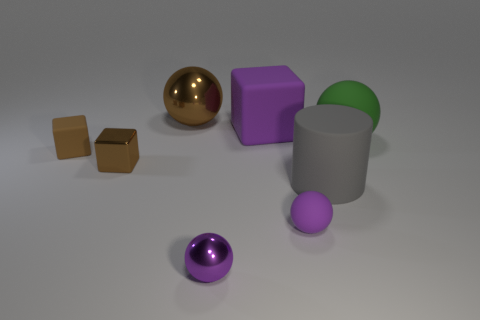Subtract 1 spheres. How many spheres are left? 3 Add 1 small yellow rubber things. How many objects exist? 9 Subtract all blocks. How many objects are left? 5 Add 5 large matte balls. How many large matte balls exist? 6 Subtract 0 blue cylinders. How many objects are left? 8 Subtract all purple things. Subtract all tiny brown matte objects. How many objects are left? 4 Add 6 metal spheres. How many metal spheres are left? 8 